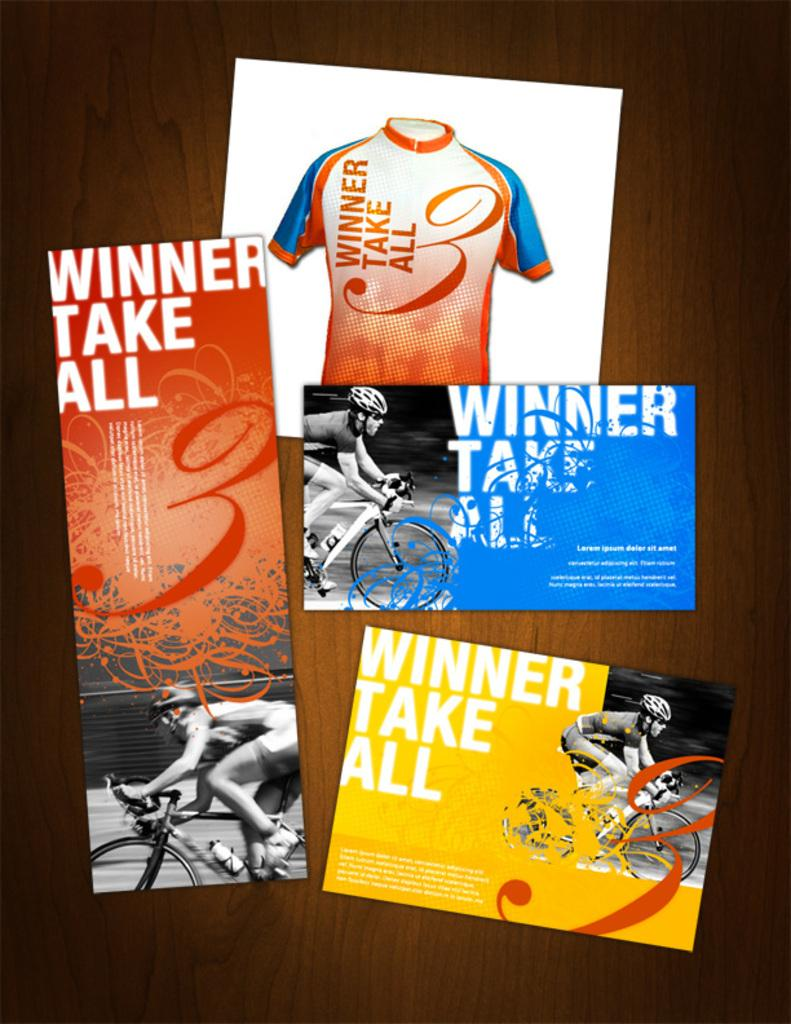<image>
Summarize the visual content of the image. A bunch of smaller cards that say winner take all. 